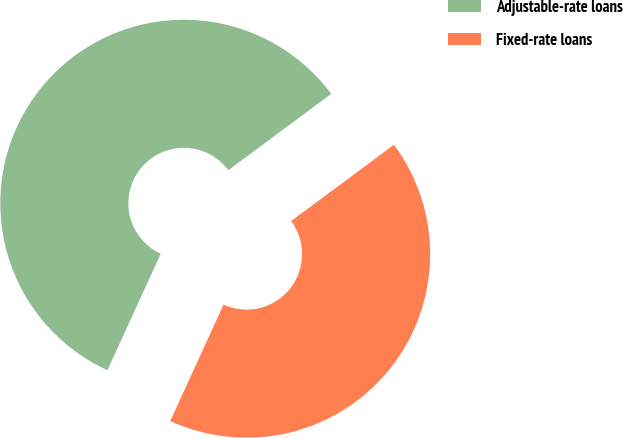Convert chart. <chart><loc_0><loc_0><loc_500><loc_500><pie_chart><fcel>Adjustable-rate loans<fcel>Fixed-rate loans<nl><fcel>58.0%<fcel>42.0%<nl></chart> 